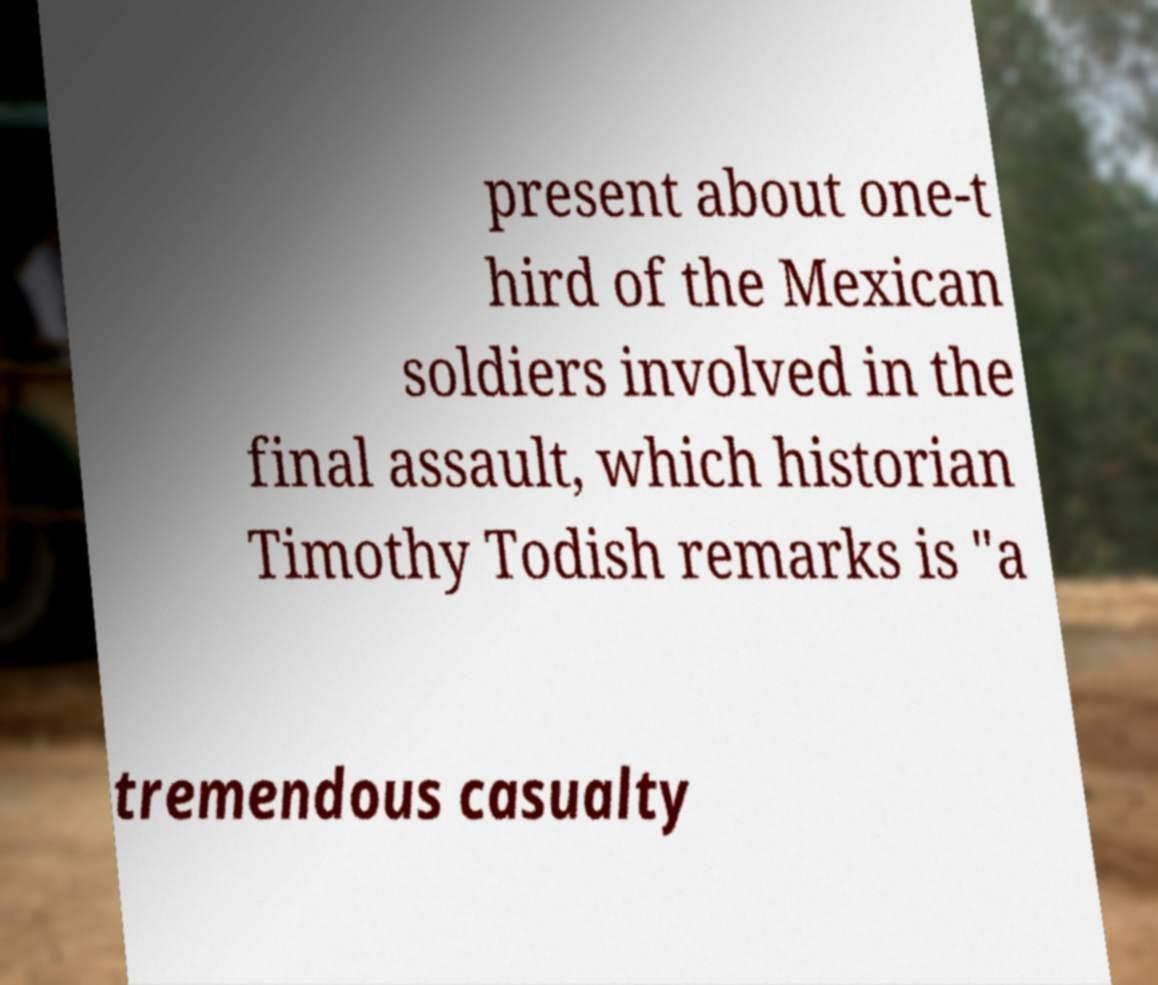I need the written content from this picture converted into text. Can you do that? present about one-t hird of the Mexican soldiers involved in the final assault, which historian Timothy Todish remarks is "a tremendous casualty 